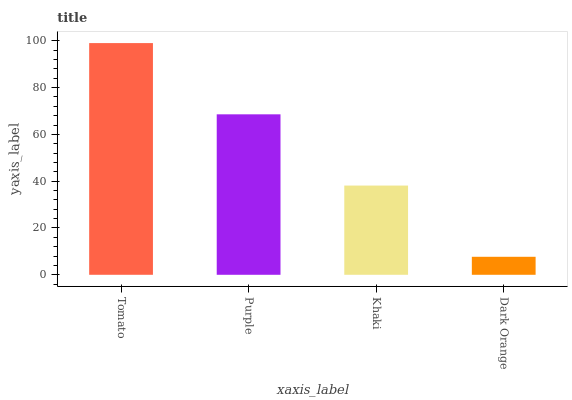Is Dark Orange the minimum?
Answer yes or no. Yes. Is Tomato the maximum?
Answer yes or no. Yes. Is Purple the minimum?
Answer yes or no. No. Is Purple the maximum?
Answer yes or no. No. Is Tomato greater than Purple?
Answer yes or no. Yes. Is Purple less than Tomato?
Answer yes or no. Yes. Is Purple greater than Tomato?
Answer yes or no. No. Is Tomato less than Purple?
Answer yes or no. No. Is Purple the high median?
Answer yes or no. Yes. Is Khaki the low median?
Answer yes or no. Yes. Is Khaki the high median?
Answer yes or no. No. Is Tomato the low median?
Answer yes or no. No. 